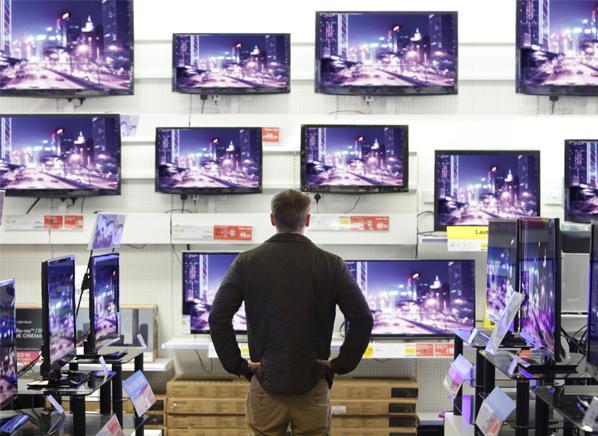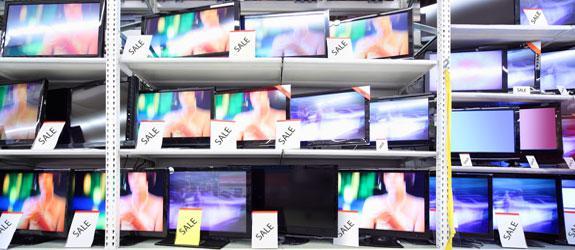The first image is the image on the left, the second image is the image on the right. Evaluate the accuracy of this statement regarding the images: "A single person is shown with some televisions.". Is it true? Answer yes or no. Yes. The first image is the image on the left, the second image is the image on the right. Considering the images on both sides, is "An image shows at least one man standing by a screen display." valid? Answer yes or no. Yes. 